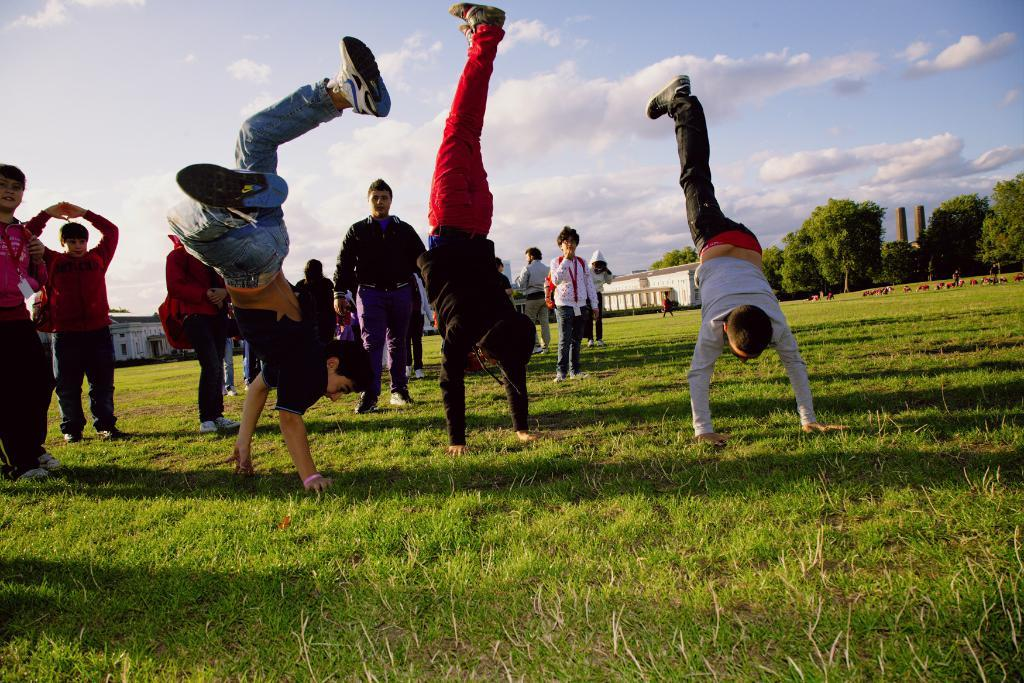What are the people in the image doing? Some people are doing exercise on the grass in the image. What type of surface are the people exercising on? The people are exercising on grass in the image. What can be seen in the background of the image? There are buildings, trees, and the sky visible in the background of the image. What type of secretary can be seen working in the wilderness in the image? There is no secretary or wilderness present in the image; it features people exercising on grass with buildings, trees, and the sky in the background. 